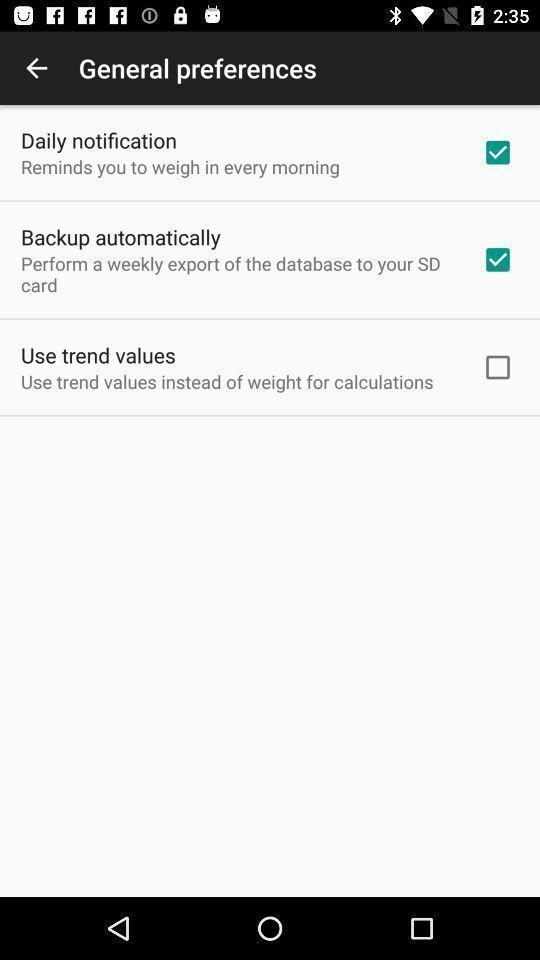Describe the content in this image. Screen display preferences settings page in a weight track app. 